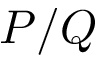Convert formula to latex. <formula><loc_0><loc_0><loc_500><loc_500>P / Q</formula> 